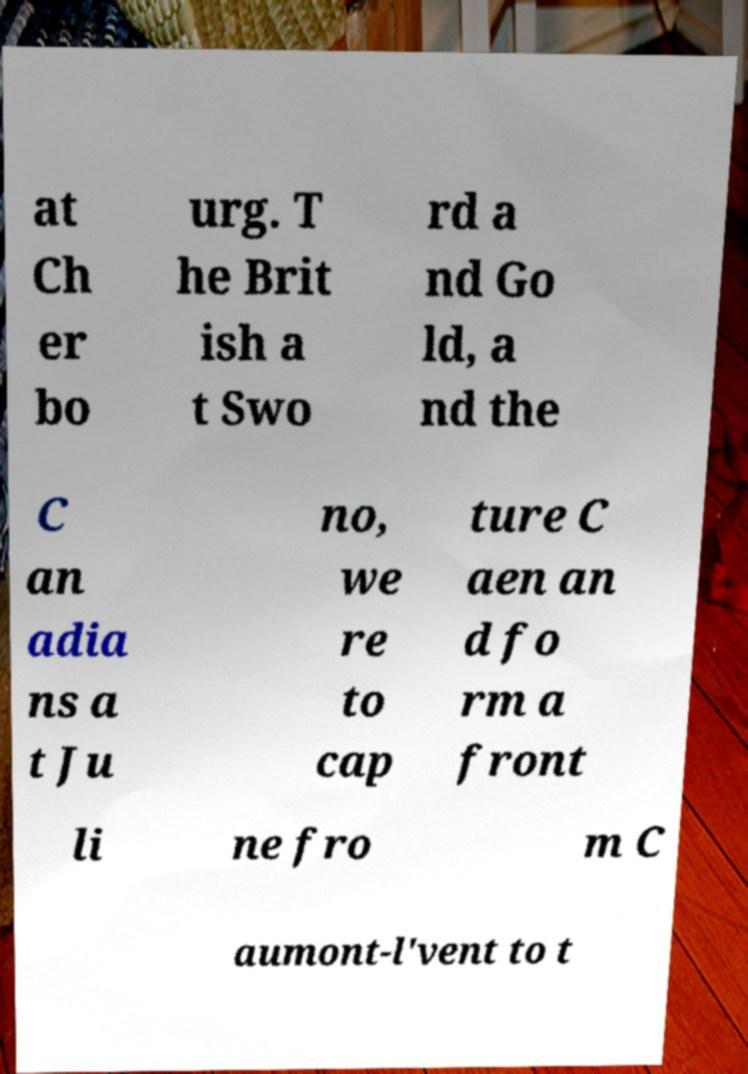There's text embedded in this image that I need extracted. Can you transcribe it verbatim? at Ch er bo urg. T he Brit ish a t Swo rd a nd Go ld, a nd the C an adia ns a t Ju no, we re to cap ture C aen an d fo rm a front li ne fro m C aumont-l'vent to t 